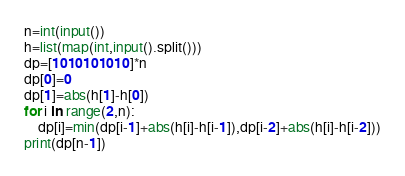Convert code to text. <code><loc_0><loc_0><loc_500><loc_500><_Python_>n=int(input())
h=list(map(int,input().split()))
dp=[1010101010]*n
dp[0]=0
dp[1]=abs(h[1]-h[0])
for i in range(2,n):
    dp[i]=min(dp[i-1]+abs(h[i]-h[i-1]),dp[i-2]+abs(h[i]-h[i-2]))
print(dp[n-1])</code> 